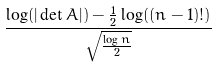Convert formula to latex. <formula><loc_0><loc_0><loc_500><loc_500>\frac { \log ( | \det A | ) - \frac { 1 } { 2 } \log ( ( n - 1 ) ! ) } { \sqrt { \frac { \log n } { 2 } } }</formula> 